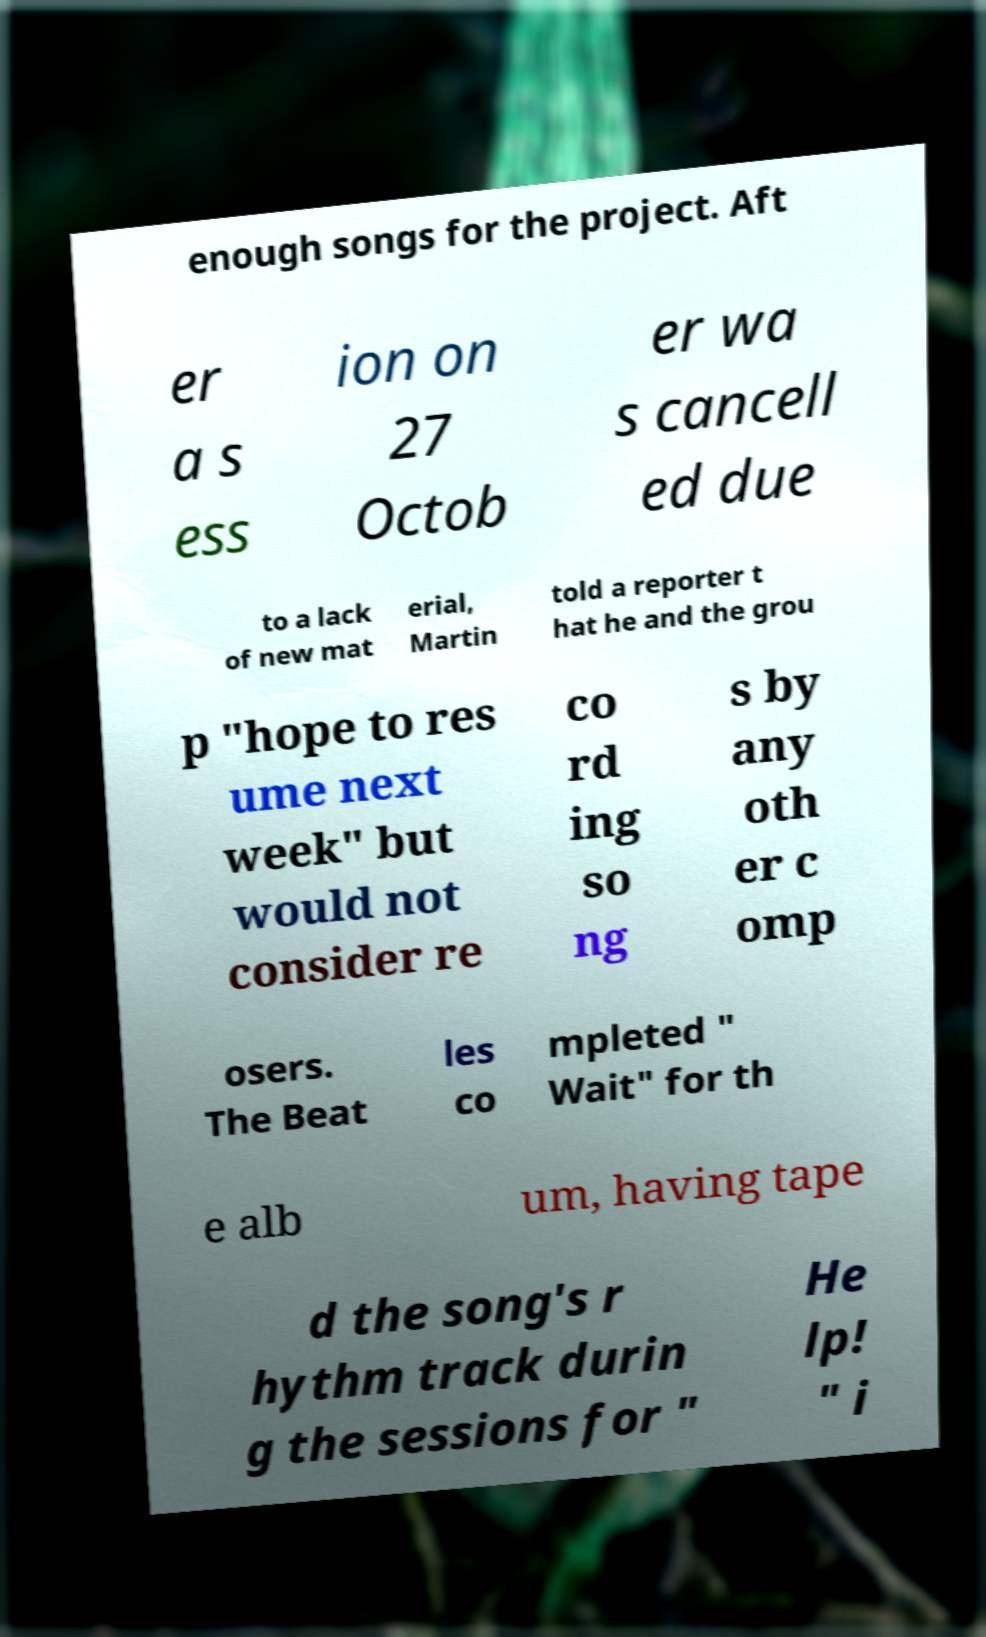Please identify and transcribe the text found in this image. enough songs for the project. Aft er a s ess ion on 27 Octob er wa s cancell ed due to a lack of new mat erial, Martin told a reporter t hat he and the grou p "hope to res ume next week" but would not consider re co rd ing so ng s by any oth er c omp osers. The Beat les co mpleted " Wait" for th e alb um, having tape d the song's r hythm track durin g the sessions for " He lp! " i 